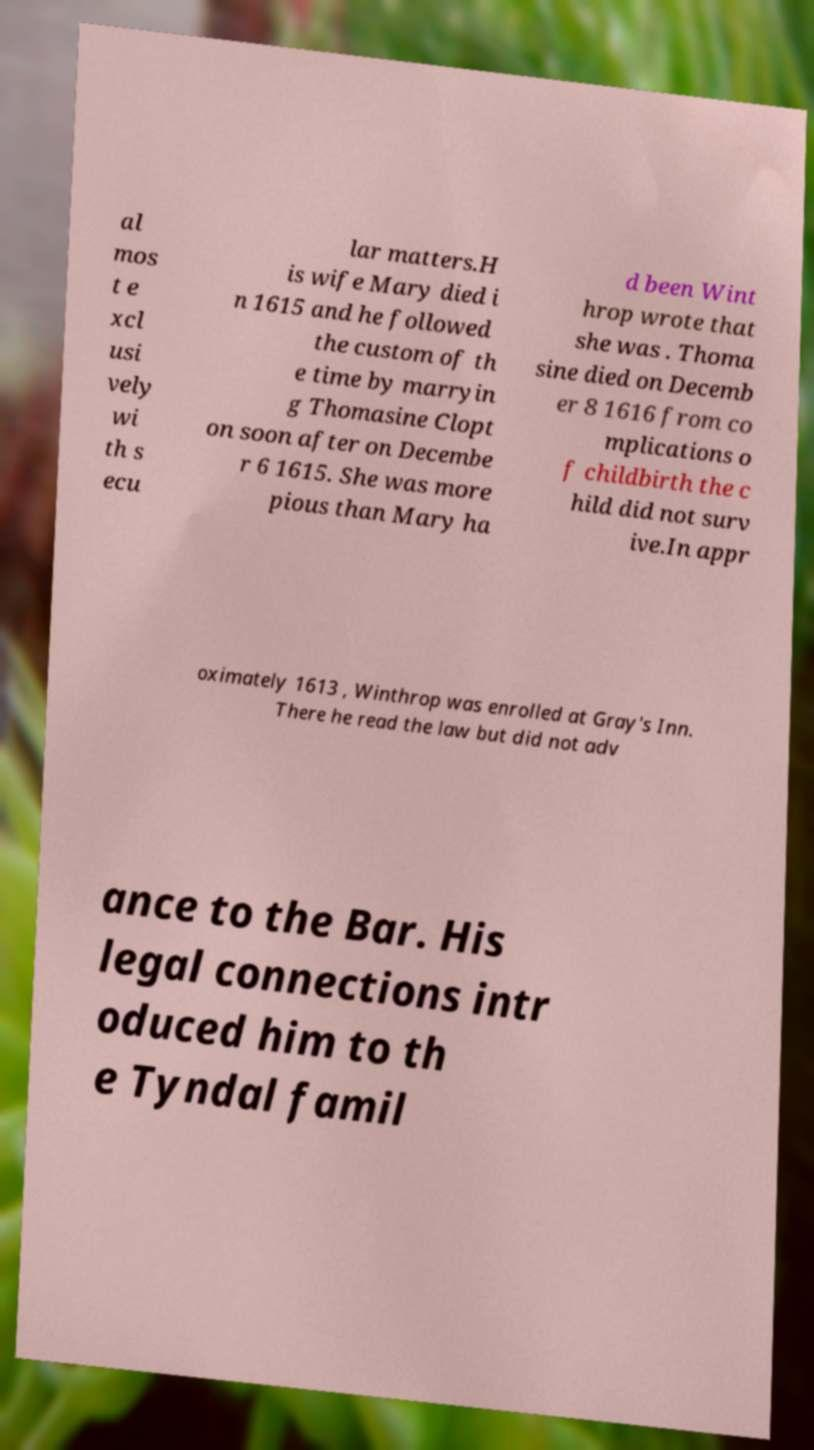Could you assist in decoding the text presented in this image and type it out clearly? al mos t e xcl usi vely wi th s ecu lar matters.H is wife Mary died i n 1615 and he followed the custom of th e time by marryin g Thomasine Clopt on soon after on Decembe r 6 1615. She was more pious than Mary ha d been Wint hrop wrote that she was . Thoma sine died on Decemb er 8 1616 from co mplications o f childbirth the c hild did not surv ive.In appr oximately 1613 , Winthrop was enrolled at Gray's Inn. There he read the law but did not adv ance to the Bar. His legal connections intr oduced him to th e Tyndal famil 